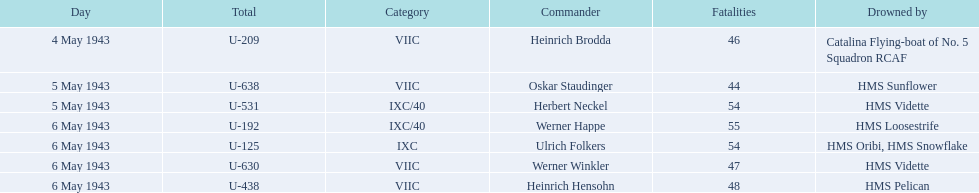What boats were lost on may 5? U-638, U-531. Who were the captains of those boats? Oskar Staudinger, Herbert Neckel. Which captain was not oskar staudinger? Herbert Neckel. 